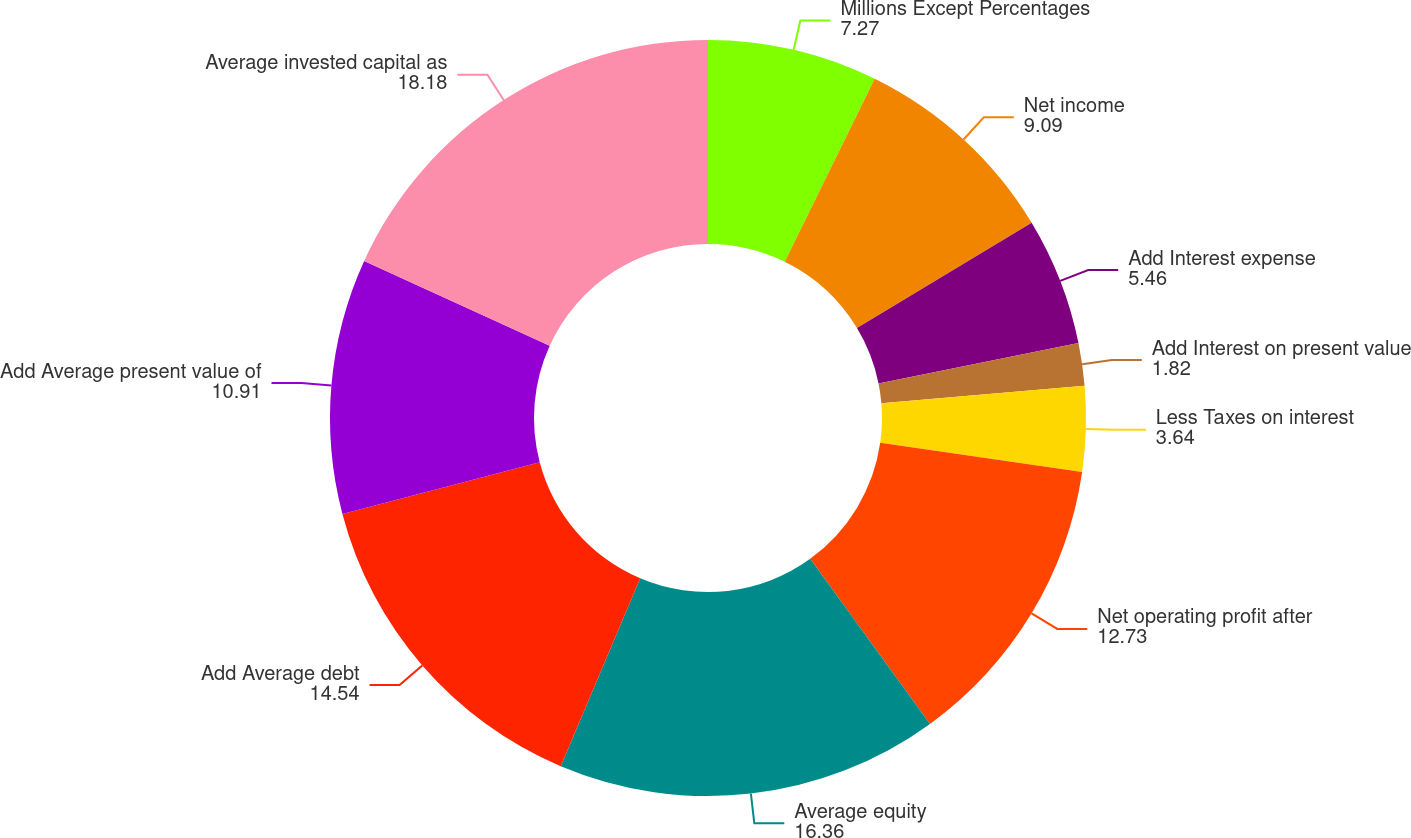<chart> <loc_0><loc_0><loc_500><loc_500><pie_chart><fcel>Millions Except Percentages<fcel>Net income<fcel>Add Interest expense<fcel>Add Interest on present value<fcel>Less Taxes on interest<fcel>Net operating profit after<fcel>Average equity<fcel>Add Average debt<fcel>Add Average present value of<fcel>Average invested capital as<nl><fcel>7.27%<fcel>9.09%<fcel>5.46%<fcel>1.82%<fcel>3.64%<fcel>12.73%<fcel>16.36%<fcel>14.54%<fcel>10.91%<fcel>18.18%<nl></chart> 